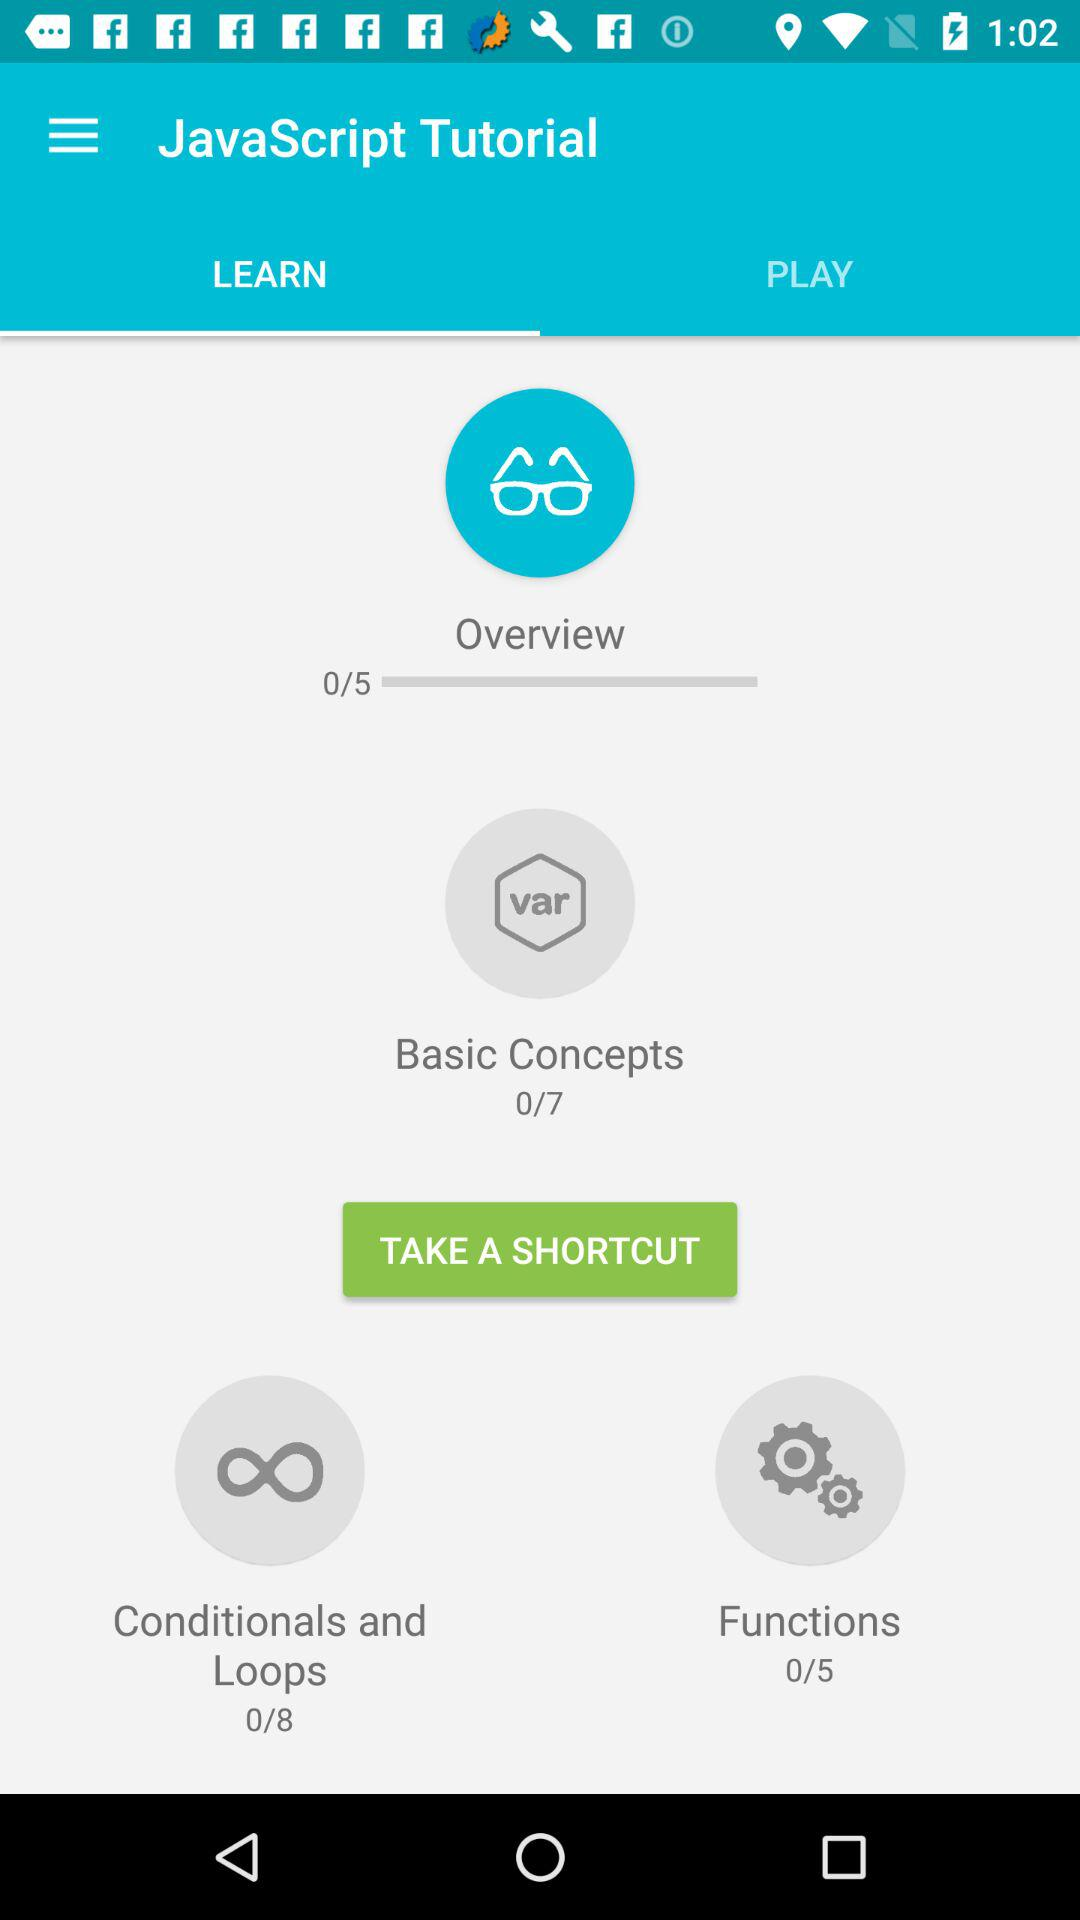How many modules are there for the topic "Basic Concepts"? There are 7 modules. 